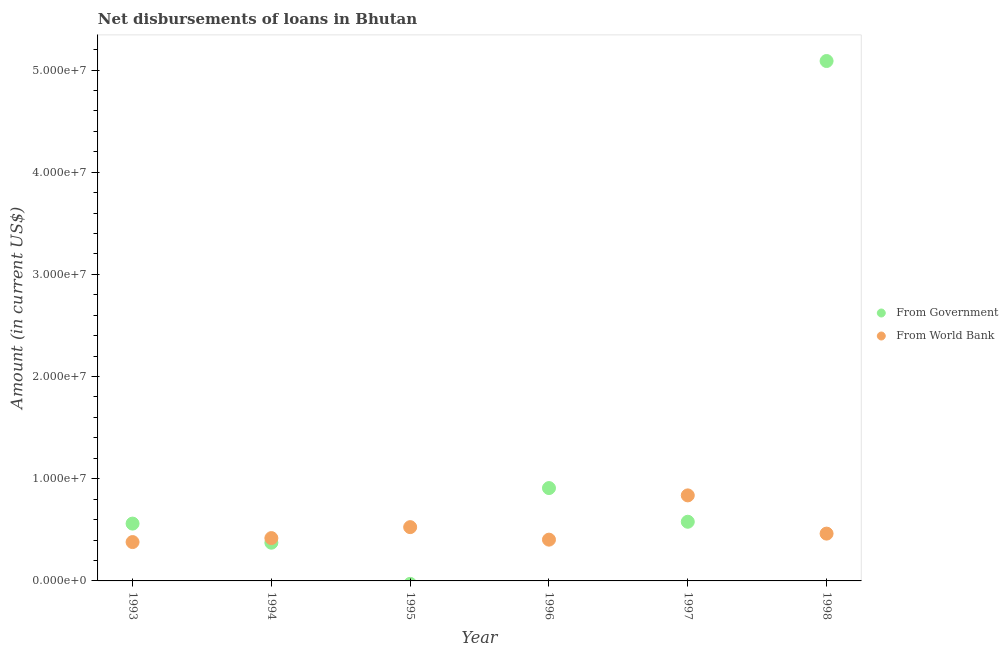How many different coloured dotlines are there?
Ensure brevity in your answer.  2. Is the number of dotlines equal to the number of legend labels?
Make the answer very short. No. What is the net disbursements of loan from world bank in 1993?
Your answer should be compact. 3.80e+06. Across all years, what is the maximum net disbursements of loan from government?
Provide a succinct answer. 5.09e+07. Across all years, what is the minimum net disbursements of loan from world bank?
Provide a short and direct response. 3.80e+06. In which year was the net disbursements of loan from government maximum?
Your answer should be compact. 1998. What is the total net disbursements of loan from government in the graph?
Your answer should be very brief. 7.51e+07. What is the difference between the net disbursements of loan from government in 1994 and that in 1996?
Ensure brevity in your answer.  -5.35e+06. What is the difference between the net disbursements of loan from government in 1993 and the net disbursements of loan from world bank in 1998?
Provide a short and direct response. 9.80e+05. What is the average net disbursements of loan from government per year?
Keep it short and to the point. 1.25e+07. In the year 1994, what is the difference between the net disbursements of loan from world bank and net disbursements of loan from government?
Your answer should be very brief. 4.51e+05. In how many years, is the net disbursements of loan from world bank greater than 28000000 US$?
Keep it short and to the point. 0. What is the ratio of the net disbursements of loan from world bank in 1994 to that in 1996?
Ensure brevity in your answer.  1.04. Is the net disbursements of loan from world bank in 1996 less than that in 1998?
Keep it short and to the point. Yes. Is the difference between the net disbursements of loan from government in 1994 and 1998 greater than the difference between the net disbursements of loan from world bank in 1994 and 1998?
Your answer should be compact. No. What is the difference between the highest and the second highest net disbursements of loan from government?
Your answer should be compact. 4.18e+07. What is the difference between the highest and the lowest net disbursements of loan from world bank?
Offer a terse response. 4.57e+06. Does the net disbursements of loan from government monotonically increase over the years?
Your answer should be very brief. No. Is the net disbursements of loan from government strictly greater than the net disbursements of loan from world bank over the years?
Give a very brief answer. No. Is the net disbursements of loan from world bank strictly less than the net disbursements of loan from government over the years?
Ensure brevity in your answer.  No. How many dotlines are there?
Your answer should be compact. 2. How many years are there in the graph?
Make the answer very short. 6. Does the graph contain grids?
Keep it short and to the point. No. How are the legend labels stacked?
Your response must be concise. Vertical. What is the title of the graph?
Offer a terse response. Net disbursements of loans in Bhutan. Does "IMF nonconcessional" appear as one of the legend labels in the graph?
Provide a short and direct response. No. What is the Amount (in current US$) in From Government in 1993?
Give a very brief answer. 5.61e+06. What is the Amount (in current US$) of From World Bank in 1993?
Give a very brief answer. 3.80e+06. What is the Amount (in current US$) in From Government in 1994?
Ensure brevity in your answer.  3.74e+06. What is the Amount (in current US$) of From World Bank in 1994?
Offer a very short reply. 4.19e+06. What is the Amount (in current US$) of From World Bank in 1995?
Provide a succinct answer. 5.26e+06. What is the Amount (in current US$) of From Government in 1996?
Your answer should be very brief. 9.09e+06. What is the Amount (in current US$) in From World Bank in 1996?
Keep it short and to the point. 4.04e+06. What is the Amount (in current US$) in From Government in 1997?
Make the answer very short. 5.79e+06. What is the Amount (in current US$) of From World Bank in 1997?
Your answer should be very brief. 8.37e+06. What is the Amount (in current US$) of From Government in 1998?
Your answer should be compact. 5.09e+07. What is the Amount (in current US$) in From World Bank in 1998?
Your answer should be very brief. 4.63e+06. Across all years, what is the maximum Amount (in current US$) in From Government?
Keep it short and to the point. 5.09e+07. Across all years, what is the maximum Amount (in current US$) of From World Bank?
Give a very brief answer. 8.37e+06. Across all years, what is the minimum Amount (in current US$) in From Government?
Your answer should be very brief. 0. Across all years, what is the minimum Amount (in current US$) in From World Bank?
Provide a short and direct response. 3.80e+06. What is the total Amount (in current US$) of From Government in the graph?
Provide a succinct answer. 7.51e+07. What is the total Amount (in current US$) of From World Bank in the graph?
Keep it short and to the point. 3.03e+07. What is the difference between the Amount (in current US$) in From Government in 1993 and that in 1994?
Ensure brevity in your answer.  1.87e+06. What is the difference between the Amount (in current US$) of From World Bank in 1993 and that in 1994?
Ensure brevity in your answer.  -3.89e+05. What is the difference between the Amount (in current US$) of From World Bank in 1993 and that in 1995?
Provide a short and direct response. -1.46e+06. What is the difference between the Amount (in current US$) in From Government in 1993 and that in 1996?
Offer a terse response. -3.48e+06. What is the difference between the Amount (in current US$) of From World Bank in 1993 and that in 1996?
Make the answer very short. -2.37e+05. What is the difference between the Amount (in current US$) in From Government in 1993 and that in 1997?
Provide a short and direct response. -1.80e+05. What is the difference between the Amount (in current US$) in From World Bank in 1993 and that in 1997?
Offer a terse response. -4.57e+06. What is the difference between the Amount (in current US$) of From Government in 1993 and that in 1998?
Your answer should be compact. -4.53e+07. What is the difference between the Amount (in current US$) of From World Bank in 1993 and that in 1998?
Provide a short and direct response. -8.28e+05. What is the difference between the Amount (in current US$) of From World Bank in 1994 and that in 1995?
Offer a terse response. -1.07e+06. What is the difference between the Amount (in current US$) of From Government in 1994 and that in 1996?
Provide a short and direct response. -5.35e+06. What is the difference between the Amount (in current US$) in From World Bank in 1994 and that in 1996?
Your response must be concise. 1.52e+05. What is the difference between the Amount (in current US$) in From Government in 1994 and that in 1997?
Offer a very short reply. -2.05e+06. What is the difference between the Amount (in current US$) in From World Bank in 1994 and that in 1997?
Make the answer very short. -4.18e+06. What is the difference between the Amount (in current US$) in From Government in 1994 and that in 1998?
Ensure brevity in your answer.  -4.71e+07. What is the difference between the Amount (in current US$) of From World Bank in 1994 and that in 1998?
Provide a succinct answer. -4.39e+05. What is the difference between the Amount (in current US$) of From World Bank in 1995 and that in 1996?
Offer a terse response. 1.22e+06. What is the difference between the Amount (in current US$) of From World Bank in 1995 and that in 1997?
Provide a succinct answer. -3.11e+06. What is the difference between the Amount (in current US$) in From World Bank in 1995 and that in 1998?
Ensure brevity in your answer.  6.34e+05. What is the difference between the Amount (in current US$) of From Government in 1996 and that in 1997?
Your answer should be compact. 3.30e+06. What is the difference between the Amount (in current US$) in From World Bank in 1996 and that in 1997?
Offer a terse response. -4.33e+06. What is the difference between the Amount (in current US$) in From Government in 1996 and that in 1998?
Your answer should be compact. -4.18e+07. What is the difference between the Amount (in current US$) in From World Bank in 1996 and that in 1998?
Ensure brevity in your answer.  -5.91e+05. What is the difference between the Amount (in current US$) of From Government in 1997 and that in 1998?
Ensure brevity in your answer.  -4.51e+07. What is the difference between the Amount (in current US$) in From World Bank in 1997 and that in 1998?
Make the answer very short. 3.74e+06. What is the difference between the Amount (in current US$) in From Government in 1993 and the Amount (in current US$) in From World Bank in 1994?
Make the answer very short. 1.42e+06. What is the difference between the Amount (in current US$) of From Government in 1993 and the Amount (in current US$) of From World Bank in 1995?
Provide a short and direct response. 3.46e+05. What is the difference between the Amount (in current US$) in From Government in 1993 and the Amount (in current US$) in From World Bank in 1996?
Keep it short and to the point. 1.57e+06. What is the difference between the Amount (in current US$) in From Government in 1993 and the Amount (in current US$) in From World Bank in 1997?
Your answer should be compact. -2.76e+06. What is the difference between the Amount (in current US$) of From Government in 1993 and the Amount (in current US$) of From World Bank in 1998?
Give a very brief answer. 9.80e+05. What is the difference between the Amount (in current US$) of From Government in 1994 and the Amount (in current US$) of From World Bank in 1995?
Provide a short and direct response. -1.52e+06. What is the difference between the Amount (in current US$) of From Government in 1994 and the Amount (in current US$) of From World Bank in 1996?
Give a very brief answer. -2.99e+05. What is the difference between the Amount (in current US$) in From Government in 1994 and the Amount (in current US$) in From World Bank in 1997?
Ensure brevity in your answer.  -4.63e+06. What is the difference between the Amount (in current US$) in From Government in 1994 and the Amount (in current US$) in From World Bank in 1998?
Make the answer very short. -8.90e+05. What is the difference between the Amount (in current US$) of From Government in 1996 and the Amount (in current US$) of From World Bank in 1997?
Offer a very short reply. 7.16e+05. What is the difference between the Amount (in current US$) of From Government in 1996 and the Amount (in current US$) of From World Bank in 1998?
Offer a terse response. 4.46e+06. What is the difference between the Amount (in current US$) of From Government in 1997 and the Amount (in current US$) of From World Bank in 1998?
Offer a very short reply. 1.16e+06. What is the average Amount (in current US$) in From Government per year?
Provide a succinct answer. 1.25e+07. What is the average Amount (in current US$) of From World Bank per year?
Keep it short and to the point. 5.05e+06. In the year 1993, what is the difference between the Amount (in current US$) in From Government and Amount (in current US$) in From World Bank?
Provide a succinct answer. 1.81e+06. In the year 1994, what is the difference between the Amount (in current US$) in From Government and Amount (in current US$) in From World Bank?
Keep it short and to the point. -4.51e+05. In the year 1996, what is the difference between the Amount (in current US$) in From Government and Amount (in current US$) in From World Bank?
Your answer should be very brief. 5.05e+06. In the year 1997, what is the difference between the Amount (in current US$) in From Government and Amount (in current US$) in From World Bank?
Your response must be concise. -2.58e+06. In the year 1998, what is the difference between the Amount (in current US$) of From Government and Amount (in current US$) of From World Bank?
Provide a succinct answer. 4.63e+07. What is the ratio of the Amount (in current US$) in From World Bank in 1993 to that in 1994?
Your answer should be very brief. 0.91. What is the ratio of the Amount (in current US$) in From World Bank in 1993 to that in 1995?
Provide a succinct answer. 0.72. What is the ratio of the Amount (in current US$) in From Government in 1993 to that in 1996?
Give a very brief answer. 0.62. What is the ratio of the Amount (in current US$) of From World Bank in 1993 to that in 1996?
Offer a very short reply. 0.94. What is the ratio of the Amount (in current US$) in From Government in 1993 to that in 1997?
Ensure brevity in your answer.  0.97. What is the ratio of the Amount (in current US$) in From World Bank in 1993 to that in 1997?
Offer a terse response. 0.45. What is the ratio of the Amount (in current US$) of From Government in 1993 to that in 1998?
Offer a very short reply. 0.11. What is the ratio of the Amount (in current US$) of From World Bank in 1993 to that in 1998?
Offer a terse response. 0.82. What is the ratio of the Amount (in current US$) in From World Bank in 1994 to that in 1995?
Give a very brief answer. 0.8. What is the ratio of the Amount (in current US$) of From Government in 1994 to that in 1996?
Give a very brief answer. 0.41. What is the ratio of the Amount (in current US$) in From World Bank in 1994 to that in 1996?
Give a very brief answer. 1.04. What is the ratio of the Amount (in current US$) of From Government in 1994 to that in 1997?
Make the answer very short. 0.65. What is the ratio of the Amount (in current US$) in From World Bank in 1994 to that in 1997?
Your answer should be very brief. 0.5. What is the ratio of the Amount (in current US$) of From Government in 1994 to that in 1998?
Keep it short and to the point. 0.07. What is the ratio of the Amount (in current US$) in From World Bank in 1994 to that in 1998?
Give a very brief answer. 0.91. What is the ratio of the Amount (in current US$) of From World Bank in 1995 to that in 1996?
Provide a succinct answer. 1.3. What is the ratio of the Amount (in current US$) in From World Bank in 1995 to that in 1997?
Offer a terse response. 0.63. What is the ratio of the Amount (in current US$) in From World Bank in 1995 to that in 1998?
Offer a terse response. 1.14. What is the ratio of the Amount (in current US$) of From Government in 1996 to that in 1997?
Offer a terse response. 1.57. What is the ratio of the Amount (in current US$) in From World Bank in 1996 to that in 1997?
Provide a succinct answer. 0.48. What is the ratio of the Amount (in current US$) of From Government in 1996 to that in 1998?
Give a very brief answer. 0.18. What is the ratio of the Amount (in current US$) of From World Bank in 1996 to that in 1998?
Offer a very short reply. 0.87. What is the ratio of the Amount (in current US$) of From Government in 1997 to that in 1998?
Offer a terse response. 0.11. What is the ratio of the Amount (in current US$) in From World Bank in 1997 to that in 1998?
Make the answer very short. 1.81. What is the difference between the highest and the second highest Amount (in current US$) in From Government?
Keep it short and to the point. 4.18e+07. What is the difference between the highest and the second highest Amount (in current US$) in From World Bank?
Your response must be concise. 3.11e+06. What is the difference between the highest and the lowest Amount (in current US$) of From Government?
Your answer should be compact. 5.09e+07. What is the difference between the highest and the lowest Amount (in current US$) of From World Bank?
Give a very brief answer. 4.57e+06. 